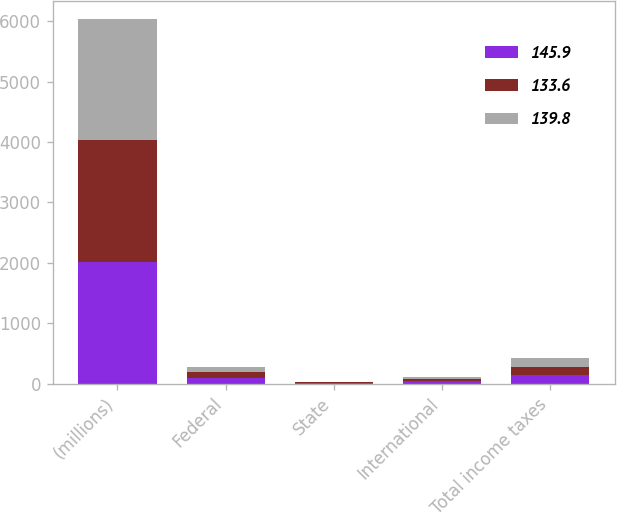<chart> <loc_0><loc_0><loc_500><loc_500><stacked_bar_chart><ecel><fcel>(millions)<fcel>Federal<fcel>State<fcel>International<fcel>Total income taxes<nl><fcel>145.9<fcel>2014<fcel>91.3<fcel>11.3<fcel>37.2<fcel>145.9<nl><fcel>133.6<fcel>2013<fcel>96.4<fcel>10.3<fcel>42.2<fcel>133.6<nl><fcel>139.8<fcel>2012<fcel>79.4<fcel>10.1<fcel>26<fcel>139.8<nl></chart> 